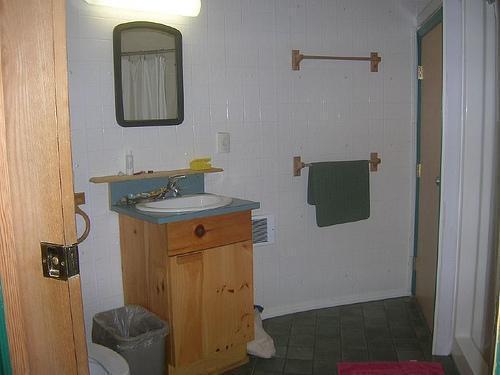How many giraffes are there?
Give a very brief answer. 0. 